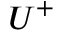<formula> <loc_0><loc_0><loc_500><loc_500>U ^ { + }</formula> 